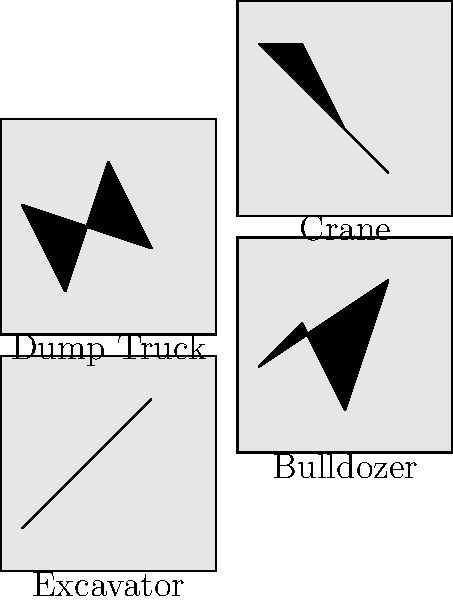As a child psychologist creating educational content for a children's TV show about construction vehicles, which silhouette would you use to represent a vehicle that can lift heavy materials to great heights on a construction site? Let's analyze each silhouette to determine which one represents a vehicle capable of lifting heavy materials to great heights:

1. Excavator: This silhouette shows a vehicle with a long arm and bucket, typically used for digging and moving earth. While it can lift materials, it's not designed for lifting to great heights.

2. Bulldozer: This silhouette depicts a vehicle with a large flat blade in front, used for pushing and leveling earth. It's not designed for lifting materials vertically.

3. Dump Truck: This silhouette shows a vehicle with a large open bed, used for transporting materials. While it can lift its bed to dump materials, it's not designed for lifting to great heights.

4. Crane: This silhouette clearly shows a tall, vertical structure with a long horizontal arm. Cranes are specifically designed for lifting heavy materials to great heights on construction sites.

For a children's TV show, the crane would be the most appropriate choice to represent a vehicle that can lift heavy materials to great heights. It's easily recognizable and directly relates to the lifting function we're looking for.
Answer: Crane 